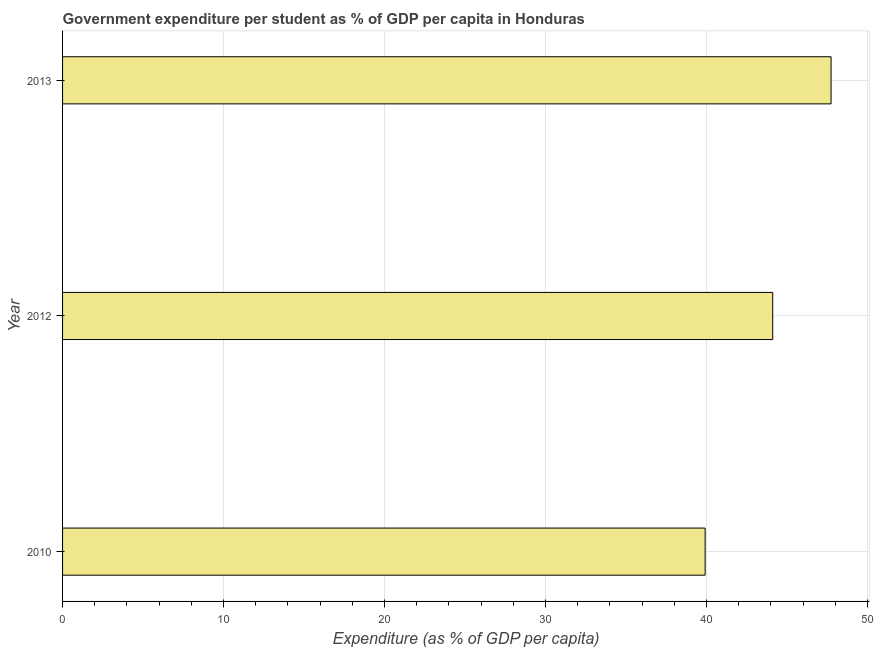Does the graph contain grids?
Keep it short and to the point. Yes. What is the title of the graph?
Give a very brief answer. Government expenditure per student as % of GDP per capita in Honduras. What is the label or title of the X-axis?
Keep it short and to the point. Expenditure (as % of GDP per capita). What is the label or title of the Y-axis?
Give a very brief answer. Year. What is the government expenditure per student in 2012?
Your response must be concise. 44.11. Across all years, what is the maximum government expenditure per student?
Offer a very short reply. 47.74. Across all years, what is the minimum government expenditure per student?
Give a very brief answer. 39.92. In which year was the government expenditure per student maximum?
Ensure brevity in your answer.  2013. What is the sum of the government expenditure per student?
Your answer should be very brief. 131.77. What is the difference between the government expenditure per student in 2012 and 2013?
Your response must be concise. -3.62. What is the average government expenditure per student per year?
Keep it short and to the point. 43.92. What is the median government expenditure per student?
Keep it short and to the point. 44.11. Do a majority of the years between 2010 and 2012 (inclusive) have government expenditure per student greater than 18 %?
Make the answer very short. Yes. What is the ratio of the government expenditure per student in 2010 to that in 2013?
Offer a terse response. 0.84. Is the difference between the government expenditure per student in 2010 and 2012 greater than the difference between any two years?
Make the answer very short. No. What is the difference between the highest and the second highest government expenditure per student?
Your answer should be very brief. 3.62. Is the sum of the government expenditure per student in 2012 and 2013 greater than the maximum government expenditure per student across all years?
Offer a very short reply. Yes. What is the difference between the highest and the lowest government expenditure per student?
Make the answer very short. 7.82. Are all the bars in the graph horizontal?
Provide a short and direct response. Yes. What is the difference between two consecutive major ticks on the X-axis?
Give a very brief answer. 10. Are the values on the major ticks of X-axis written in scientific E-notation?
Offer a very short reply. No. What is the Expenditure (as % of GDP per capita) in 2010?
Provide a succinct answer. 39.92. What is the Expenditure (as % of GDP per capita) in 2012?
Your answer should be very brief. 44.11. What is the Expenditure (as % of GDP per capita) in 2013?
Provide a short and direct response. 47.74. What is the difference between the Expenditure (as % of GDP per capita) in 2010 and 2012?
Make the answer very short. -4.2. What is the difference between the Expenditure (as % of GDP per capita) in 2010 and 2013?
Make the answer very short. -7.82. What is the difference between the Expenditure (as % of GDP per capita) in 2012 and 2013?
Offer a very short reply. -3.63. What is the ratio of the Expenditure (as % of GDP per capita) in 2010 to that in 2012?
Give a very brief answer. 0.91. What is the ratio of the Expenditure (as % of GDP per capita) in 2010 to that in 2013?
Keep it short and to the point. 0.84. What is the ratio of the Expenditure (as % of GDP per capita) in 2012 to that in 2013?
Make the answer very short. 0.92. 